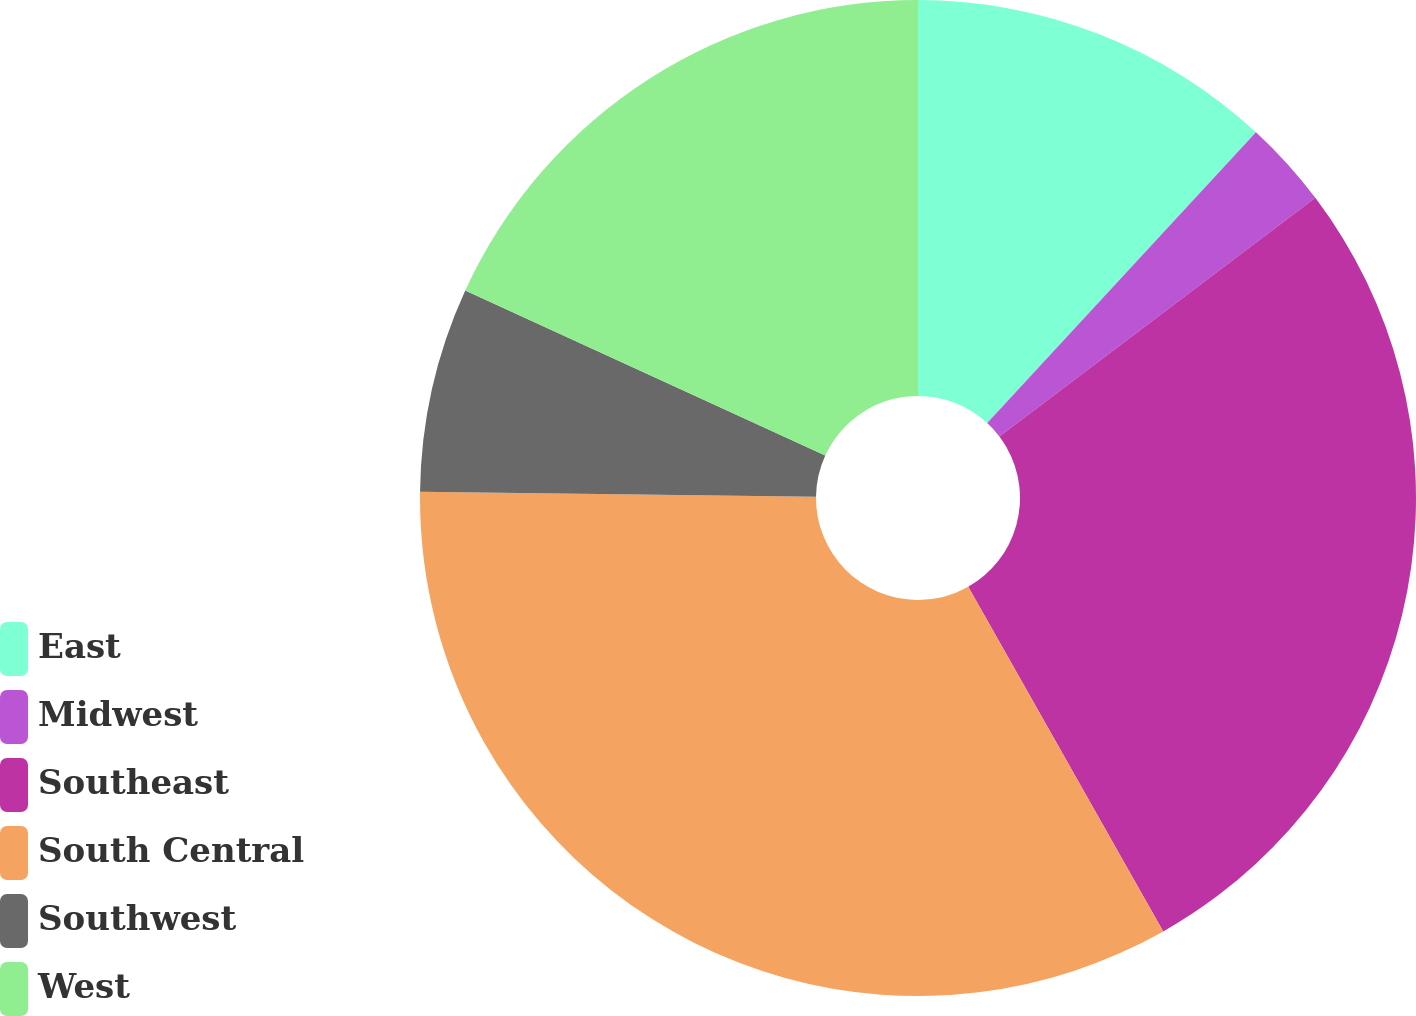<chart> <loc_0><loc_0><loc_500><loc_500><pie_chart><fcel>East<fcel>Midwest<fcel>Southeast<fcel>South Central<fcel>Southwest<fcel>West<nl><fcel>11.87%<fcel>2.83%<fcel>27.1%<fcel>33.39%<fcel>6.64%<fcel>18.16%<nl></chart> 